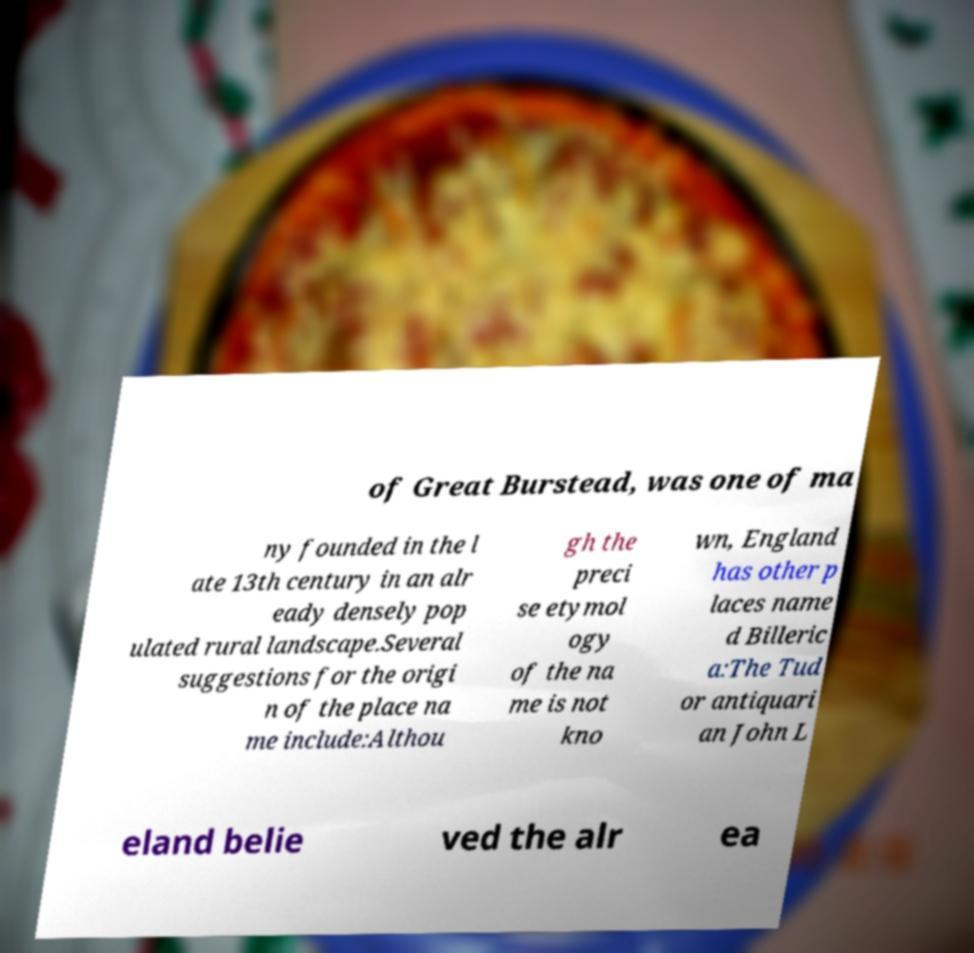What messages or text are displayed in this image? I need them in a readable, typed format. of Great Burstead, was one of ma ny founded in the l ate 13th century in an alr eady densely pop ulated rural landscape.Several suggestions for the origi n of the place na me include:Althou gh the preci se etymol ogy of the na me is not kno wn, England has other p laces name d Billeric a:The Tud or antiquari an John L eland belie ved the alr ea 